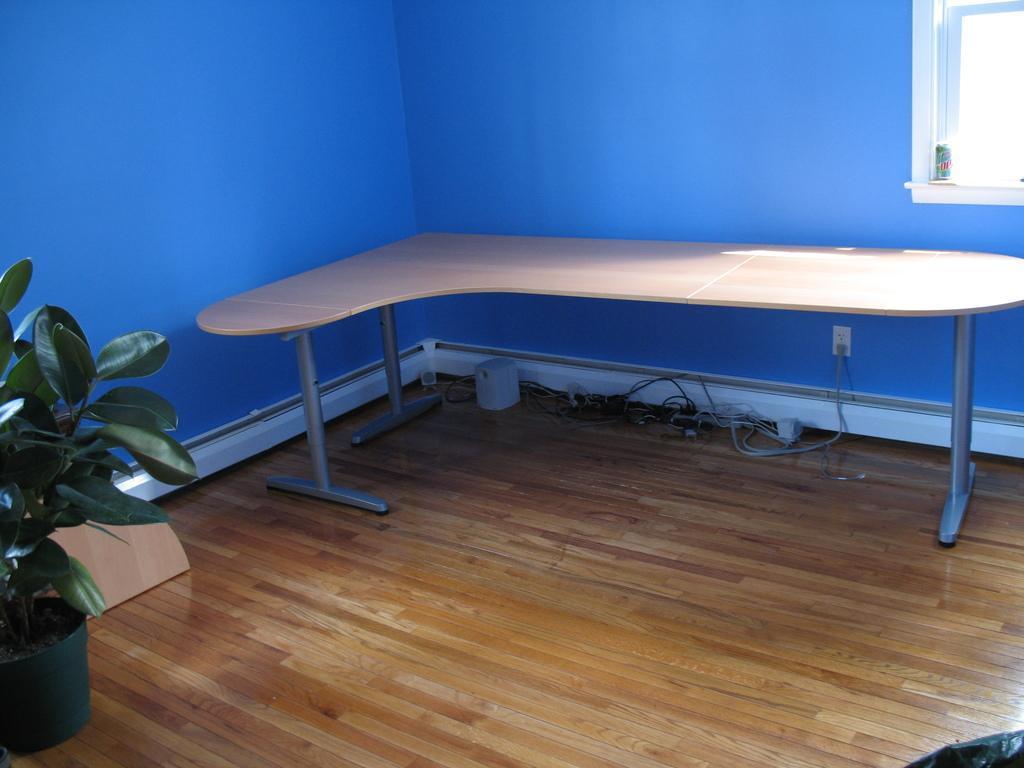Could you give a brief overview of what you see in this image? This is the wooden table. Here is the window with the glass door. This is the house plant. I can see a small object, which is under the table. I think these are the cables. This looks like a socket, which is attached to the wall. I can see the tin, which is placed near the window. This is the wall, which is blue in color. 